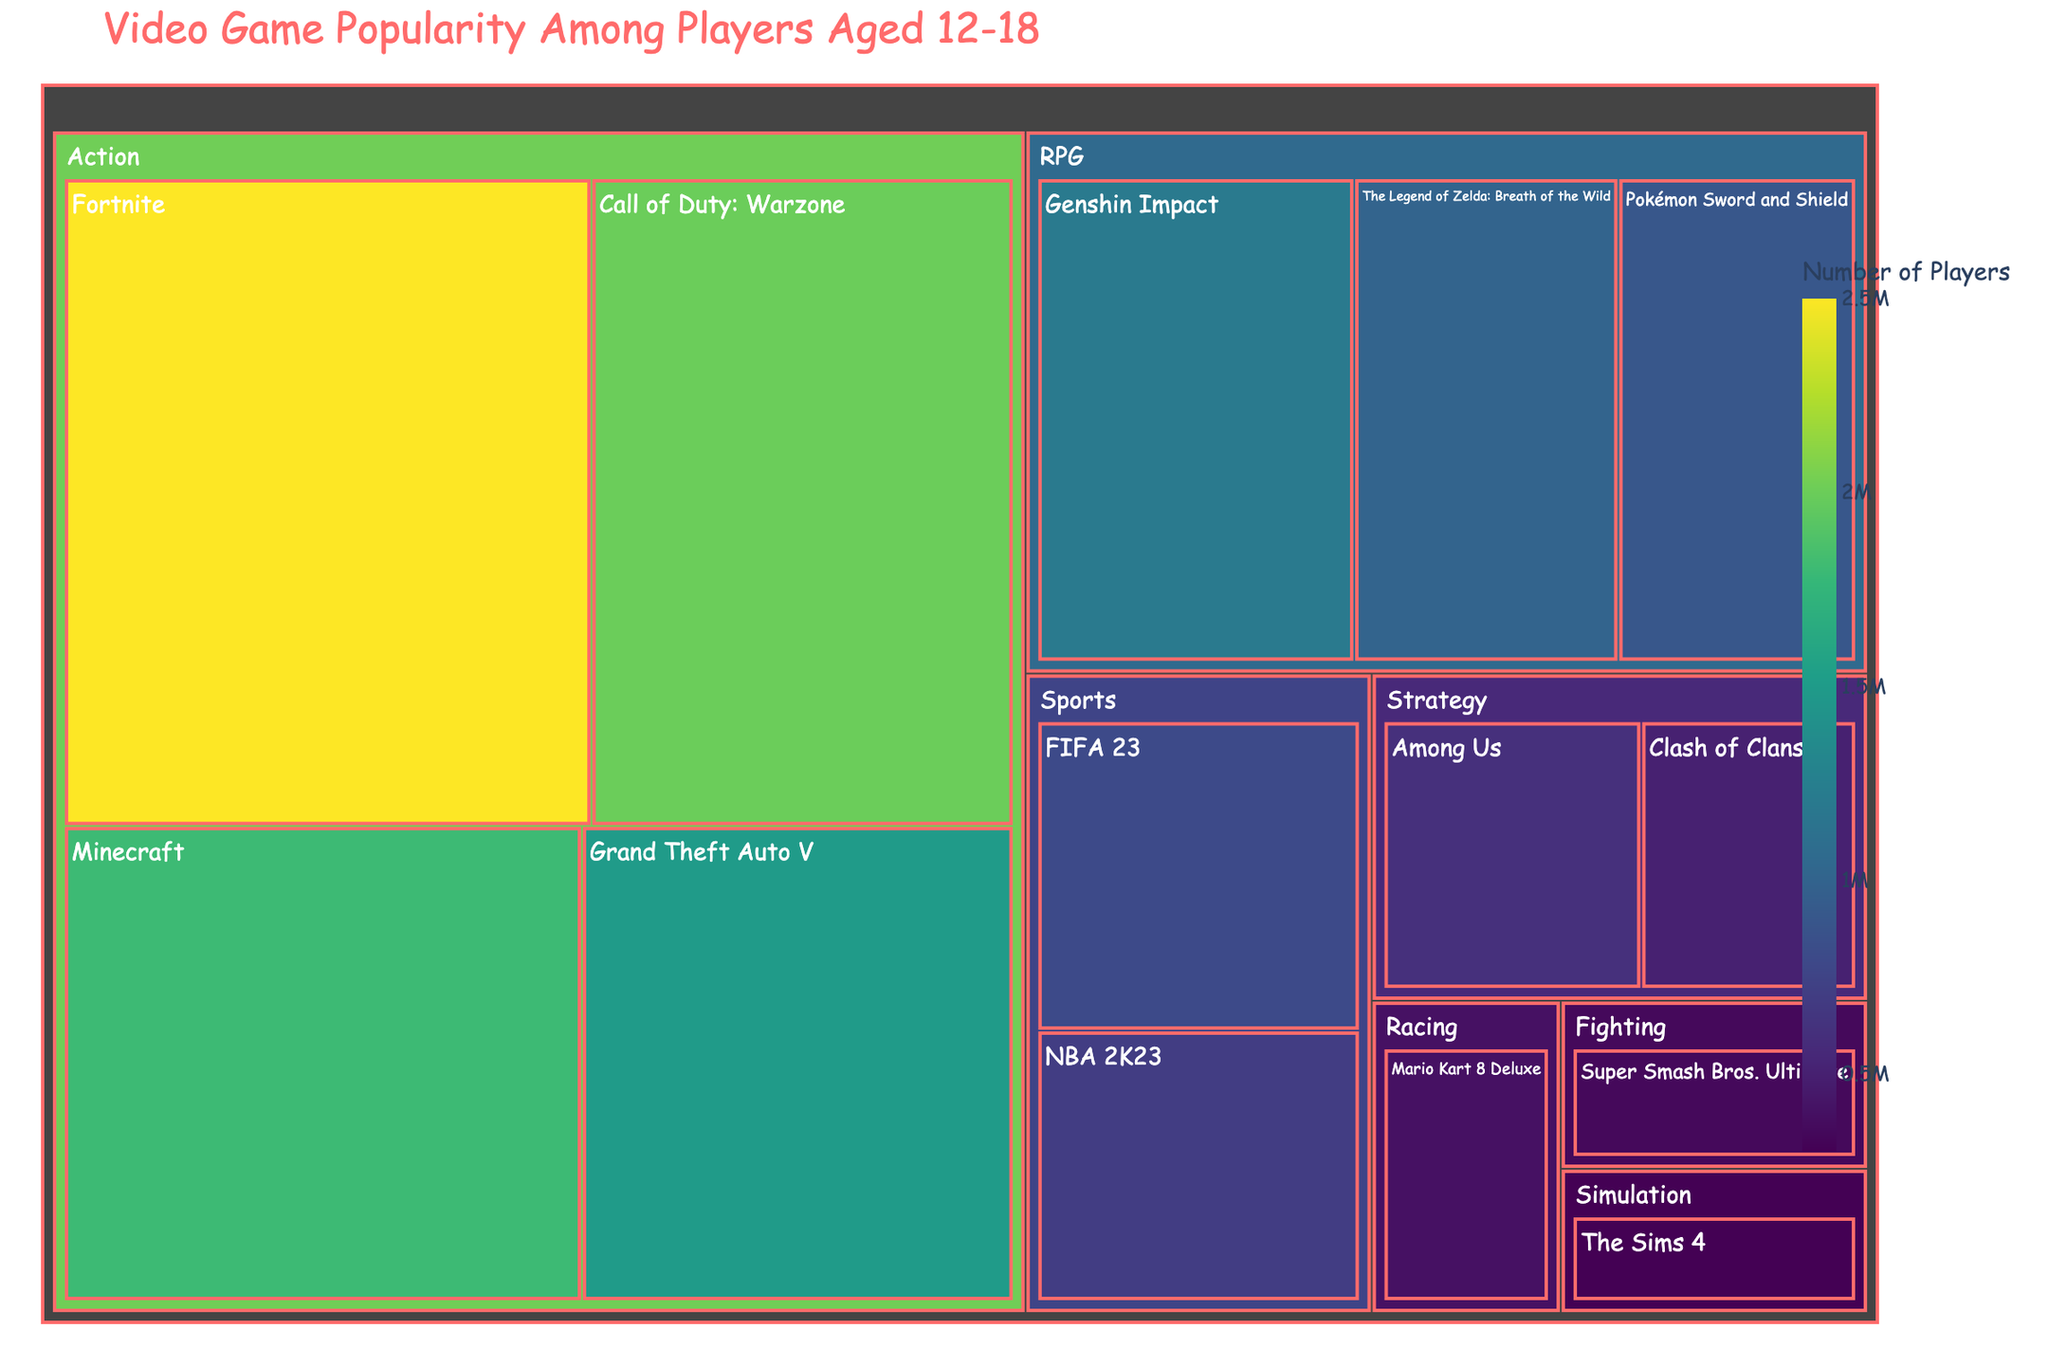What's the most popular video game genre among players aged 12-18? Looking at the largest section in the treemap, the Action genre has the highest number of players, total being the combined sizes of "Fortnite", "Call of Duty: Warzone", "Minecraft", and "Grand Theft Auto V".
Answer: Action Which game has the highest number of players in the RPG genre? Within the RPG section, "Genshin Impact" appears to be the largest, implying it has the highest number of players among RPG games.
Answer: Genshin Impact How many players prefer Fortnite compared to Among Us? Fortnite falls under the Action genre with 2,500,000 players and Among Us under the Strategy genre with 600,000 players. Subtracting the latter from the former gives the difference. 2,500,000 - 600,000 = 1,900,000.
Answer: 1,900,000 What is the total number of players for games listed under the Strategy genre? Summing the players for "Among Us" and "Clash of Clans": 600,000 + 500,000 = 1,100,000.
Answer: 1,100,000 Which game has more players: Grand Theft Auto V or FIFA 23? Comparing the size of their corresponding sections, "Grand Theft Auto V" has 1,500,000 players while "FIFA 23" has 800,000 players.
Answer: Grand Theft Auto V What is the least popular game among the listed ones? Looking at the smallest section in the treemap, "The Sims 4" under the Simulation genre has the least number of players.
Answer: The Sims 4 What's the combined number of players for all Action genre games? Summing up the players for all Action genre games: 2,500,000 (Fortnite) + 2,000,000 (Call of Duty: Warzone) + 1,800,000 (Minecraft) + 1,500,000 (Grand Theft Auto V) = 7,800,000.
Answer: 7,800,000 Which genre has more players: Racing or Fighting? Comparing the sizes of Racing (Mario Kart 8 Deluxe with 400,000 players) and Fighting (Super Smash Bros. Ultimate with 350,000 players) shows that Racing has more players.
Answer: Racing What is the average number of players for games within the RPG genre? The RPG genre has three games: Genshin Impact (1,200,000), The Legend of Zelda: Breath of the Wild (1,000,000), and Pokémon Sword and Shield (900,000). Their average is (1,200,000 + 1,000,000 + 900,000) / 3 = 1,033,333.33.
Answer: 1,033,333 